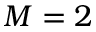Convert formula to latex. <formula><loc_0><loc_0><loc_500><loc_500>M = 2</formula> 